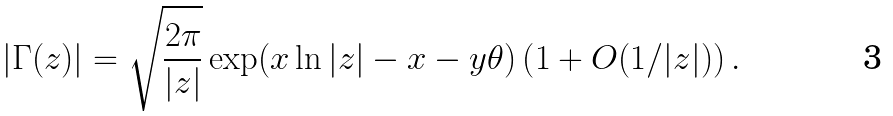Convert formula to latex. <formula><loc_0><loc_0><loc_500><loc_500>| \Gamma ( z ) | = \sqrt { \frac { 2 \pi } { | z | } } \exp ( x \ln | z | - x - y \theta ) \left ( 1 + O ( 1 / | z | ) \right ) .</formula> 